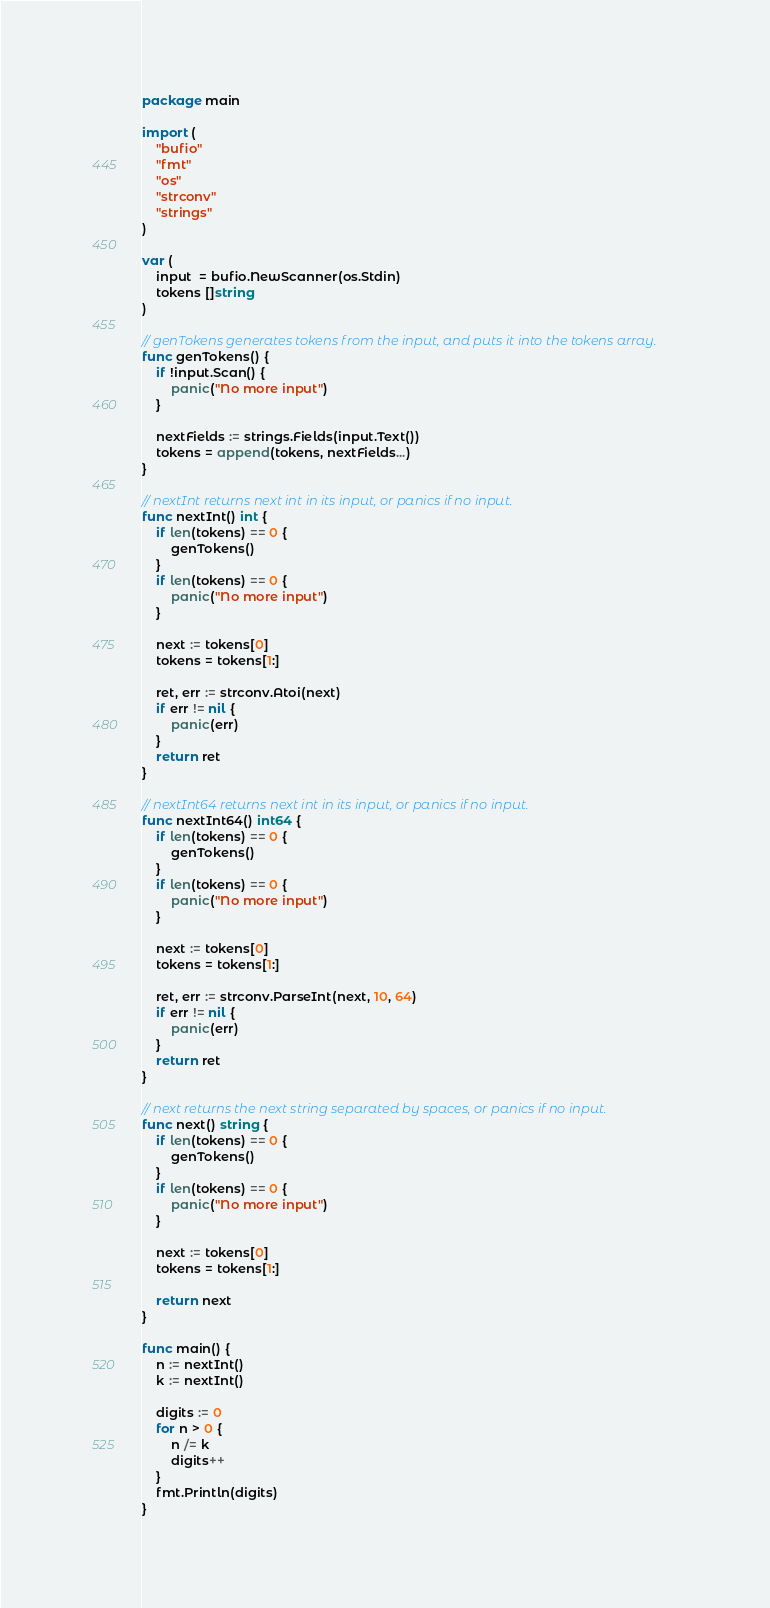Convert code to text. <code><loc_0><loc_0><loc_500><loc_500><_Go_>package main

import (
	"bufio"
	"fmt"
	"os"
	"strconv"
	"strings"
)

var (
	input  = bufio.NewScanner(os.Stdin)
	tokens []string
)

// genTokens generates tokens from the input, and puts it into the tokens array.
func genTokens() {
	if !input.Scan() {
		panic("No more input")
	}

	nextFields := strings.Fields(input.Text())
	tokens = append(tokens, nextFields...)
}

// nextInt returns next int in its input, or panics if no input.
func nextInt() int {
	if len(tokens) == 0 {
		genTokens()
	}
	if len(tokens) == 0 {
		panic("No more input")
	}

	next := tokens[0]
	tokens = tokens[1:]

	ret, err := strconv.Atoi(next)
	if err != nil {
		panic(err)
	}
	return ret
}

// nextInt64 returns next int in its input, or panics if no input.
func nextInt64() int64 {
	if len(tokens) == 0 {
		genTokens()
	}
	if len(tokens) == 0 {
		panic("No more input")
	}

	next := tokens[0]
	tokens = tokens[1:]

	ret, err := strconv.ParseInt(next, 10, 64)
	if err != nil {
		panic(err)
	}
	return ret
}

// next returns the next string separated by spaces, or panics if no input.
func next() string {
	if len(tokens) == 0 {
		genTokens()
	}
	if len(tokens) == 0 {
		panic("No more input")
	}

	next := tokens[0]
	tokens = tokens[1:]

	return next
}

func main() {
	n := nextInt()
	k := nextInt()

	digits := 0
	for n > 0 {
		n /= k
		digits++
	}
	fmt.Println(digits)
}
</code> 